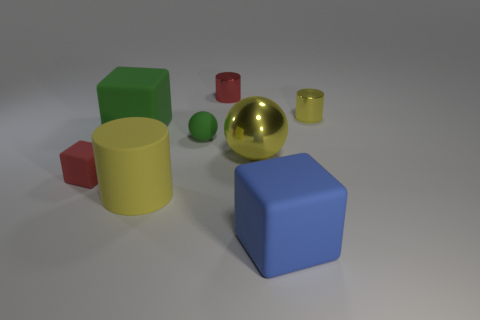How many other large cylinders are the same color as the large matte cylinder?
Offer a terse response. 0. What number of tiny gray balls have the same material as the big yellow sphere?
Offer a terse response. 0. How many things are tiny yellow metallic cylinders or objects that are left of the tiny green thing?
Offer a very short reply. 4. What is the color of the cylinder that is behind the metal cylinder right of the big cube that is in front of the red cube?
Your answer should be very brief. Red. What is the size of the shiny cylinder that is left of the big sphere?
Give a very brief answer. Small. What number of small objects are yellow cylinders or metallic balls?
Your answer should be compact. 1. There is a cube that is both in front of the rubber sphere and on the right side of the small rubber cube; what is its color?
Make the answer very short. Blue. Is there another big shiny thing of the same shape as the large yellow metallic thing?
Make the answer very short. No. What is the material of the large green cube?
Offer a terse response. Rubber. There is a red rubber block; are there any big yellow balls in front of it?
Your response must be concise. No. 